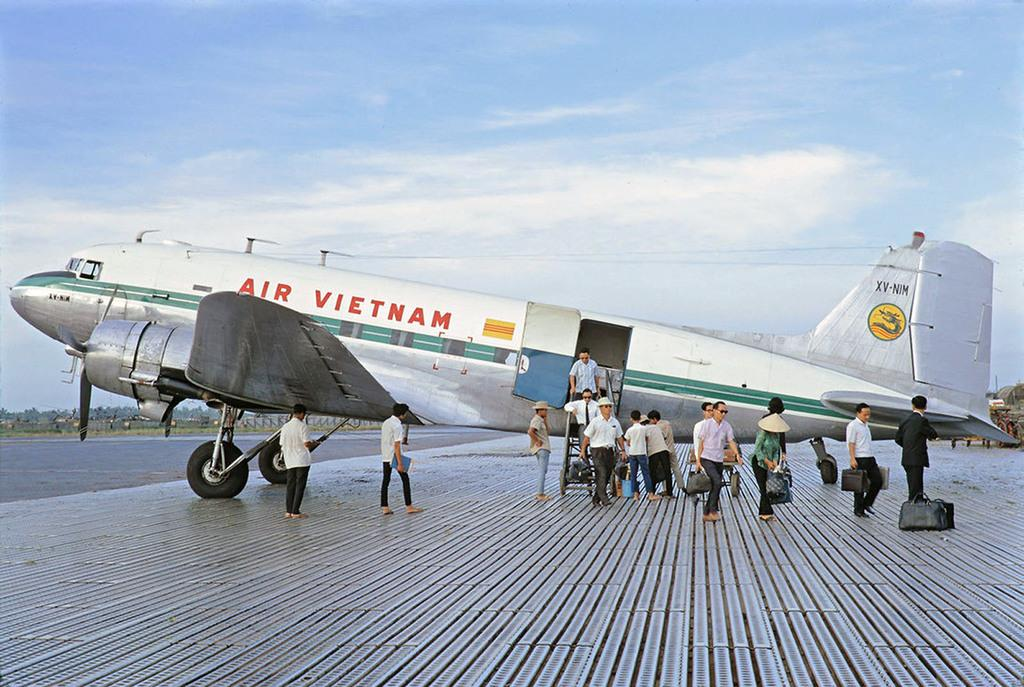What is happening on the runway in the image? There are persons standing on the runway in the image. What can be seen in the background of the image? There is an airplane in the image. What is the condition of the sky in the image? Clouds are visible in the sky. What type of sidewalk can be seen near the persons standing on the runway? There is no sidewalk present in the image; it features a runway with persons standing on it. What time of day is it in the image? The provided facts do not give any information about the time of day, so it cannot be determined from the image. 